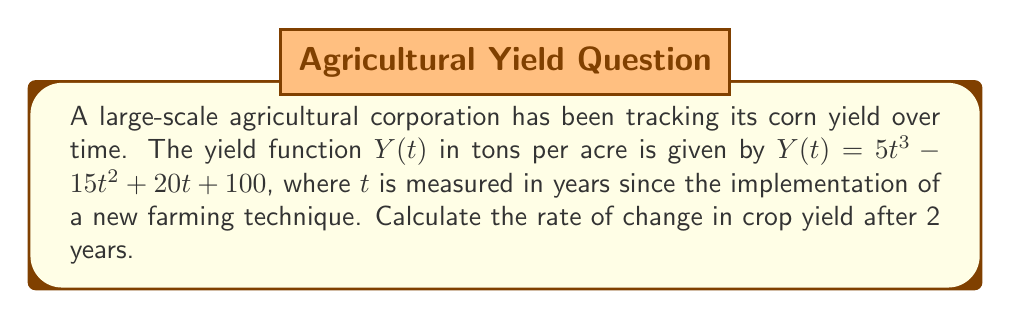Could you help me with this problem? To find the rate of change in crop yield after 2 years, we need to calculate the derivative of the yield function $Y(t)$ and evaluate it at $t=2$. Let's follow these steps:

1) First, let's find the derivative of $Y(t)$:
   $$Y'(t) = \frac{d}{dt}(5t^3 - 15t^2 + 20t + 100)$$
   
2) Using the power rule and constant rule of differentiation:
   $$Y'(t) = 15t^2 - 30t + 20$$

3) This derivative function $Y'(t)$ represents the instantaneous rate of change of yield with respect to time.

4) Now, we need to evaluate $Y'(t)$ at $t=2$:
   $$Y'(2) = 15(2)^2 - 30(2) + 20$$

5) Simplify:
   $$Y'(2) = 15(4) - 60 + 20 = 60 - 60 + 20 = 20$$

Therefore, after 2 years, the rate of change in crop yield is 20 tons per acre per year.
Answer: 20 tons/acre/year 